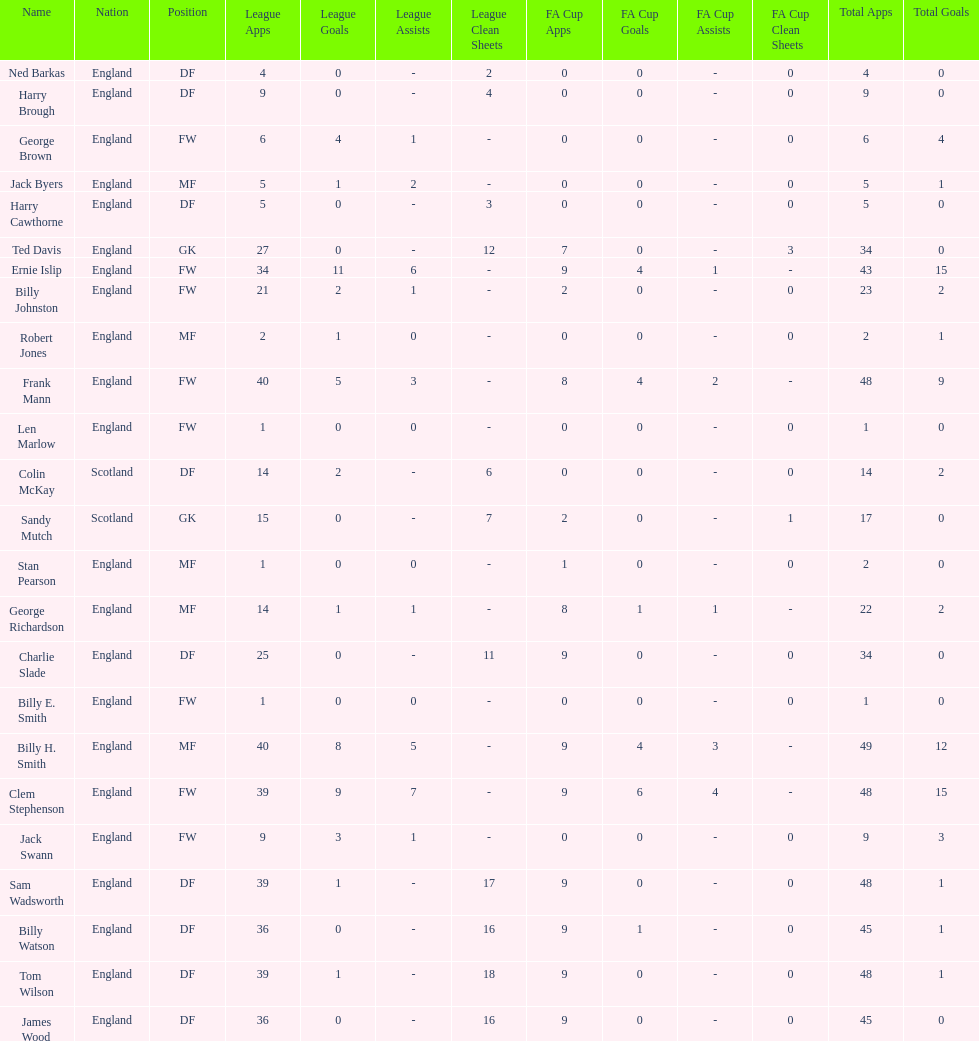Average number of goals scored by players from scotland 1. 